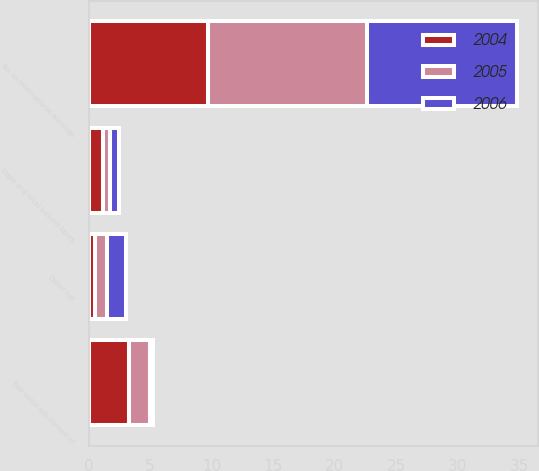<chart> <loc_0><loc_0><loc_500><loc_500><stacked_bar_chart><ecel><fcel>State and local income taxes<fcel>Tax on international earnings<fcel>Fair value adjustment of<fcel>Other net<nl><fcel>2004<fcel>1.2<fcel>9.7<fcel>3.3<fcel>0.5<nl><fcel>2006<fcel>0.8<fcel>12.2<fcel>0.2<fcel>1.5<nl><fcel>2005<fcel>0.5<fcel>12.9<fcel>1.7<fcel>1<nl></chart> 